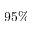<formula> <loc_0><loc_0><loc_500><loc_500>9 5 \%</formula> 